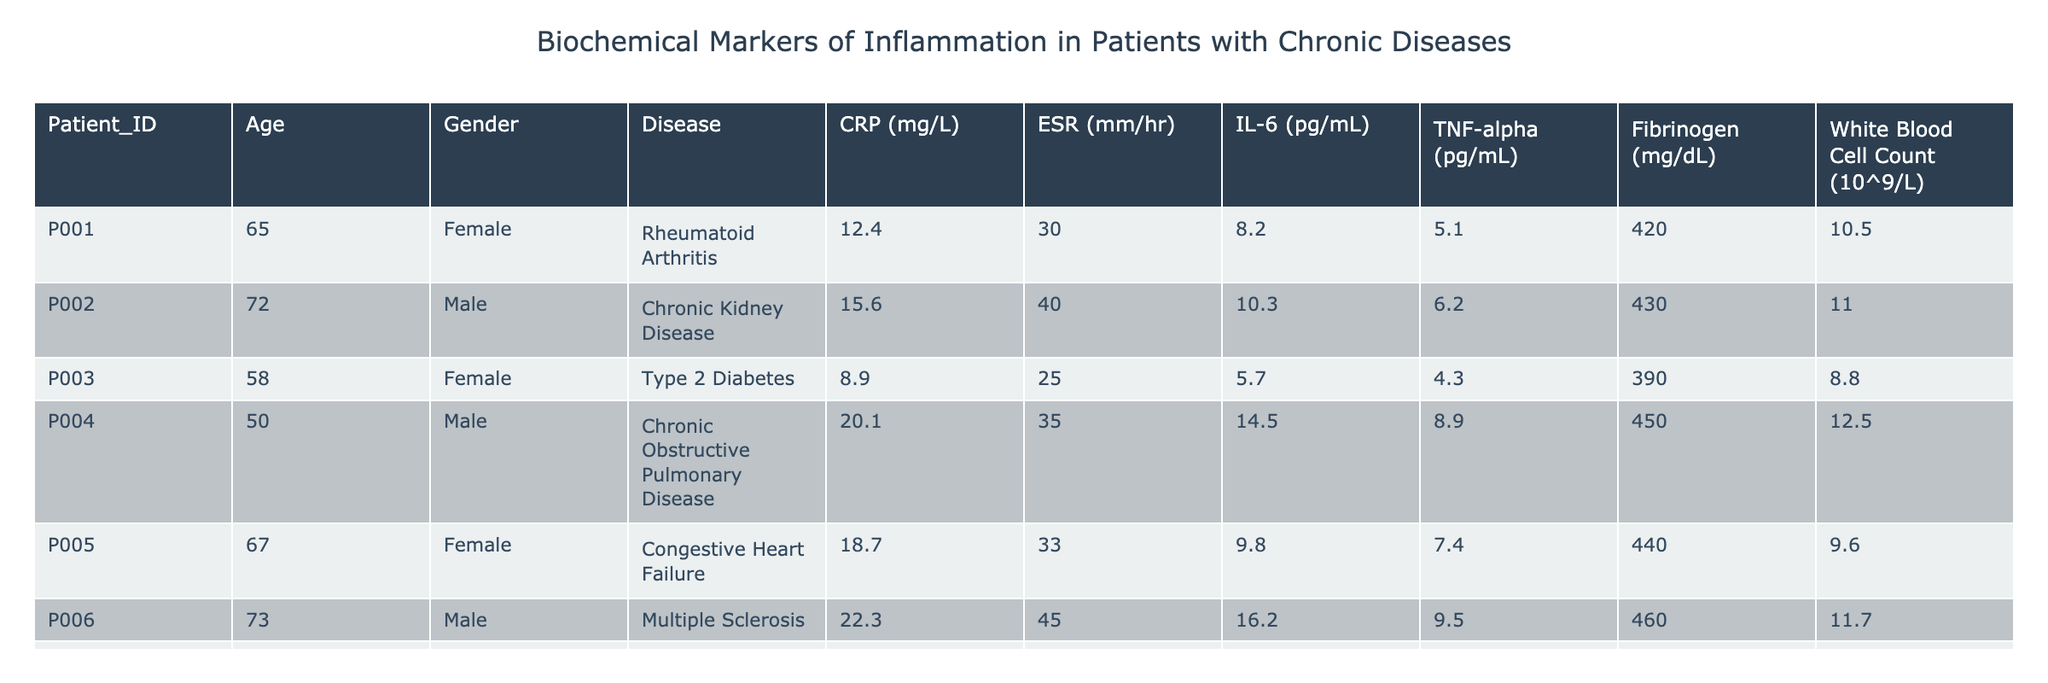What is the CRP value for the patient with Chronic Kidney Disease? By checking the row corresponding to Chronic Kidney Disease (P002), I can see that the CRP value listed in the table is 15.6 mg/L.
Answer: 15.6 mg/L Which patient has the highest IL-6 level? Looking through the IL-6 column, I find that the highest value is 16.2 pg/mL for the patient with Multiple Sclerosis (P006).
Answer: P006 What is the average ESR for patients with rheumatoid arthritis and congestive heart failure? The patients with rheumatoid arthritis (P001) and congestive heart failure (P005) have ESR values of 30 mm/hr and 33 mm/hr respectively. Adding these (30 + 33 = 63) and dividing by 2 gives an average ESR of 31.5 mm/hr.
Answer: 31.5 mm/hr Is the white blood cell count for males generally higher than for females? Looking at the table, the male patients have white blood cell counts of 11.0, 12.5, 11.7, while the female patients have counts of 10.5, 9.6, and 9.0. The averages for males and females are 11.75 (higher) and 9.7 (lower), thus answering yes to this question.
Answer: Yes What is the range of fibrinogen levels among the patients listed? By scanning the fibrinogen column, the lowest value is 390 mg/dL (P003) and the highest is 470 mg/dL (P008). The range is calculated as 470 - 390 = 80 mg/dL.
Answer: 80 mg/dL What is the total TNF-alpha value for all patients? I will sum the TNF-alpha values from the table: 5.1 + 6.2 + 4.3 + 8.9 + 7.4 + 9.5 + 5.4 + 8.1 = 54.9 pg/mL.
Answer: 54.9 pg/mL How many patients have CRP levels greater than 15 mg/L? Checking the CRP column, I find that there are four patients (P002, P004, P005, and P006) with CRP levels above 15 mg/L.
Answer: 4 Which disease has the highest average age of patients? The ages of patients in each disease category can be computed: Rheumatoid Arthritis (65), Chronic Kidney Disease (72), Type 2 Diabetes (58), Chronic Obstructive Pulmonary Disease (50), Congestive Heart Failure (67), Multiple Sclerosis (73), Psoriatic Arthritis (55), and Cardiovascular Disease (62). The highest average age is for Chronic Kidney Disease at 72 years.
Answer: Chronic Kidney Disease 